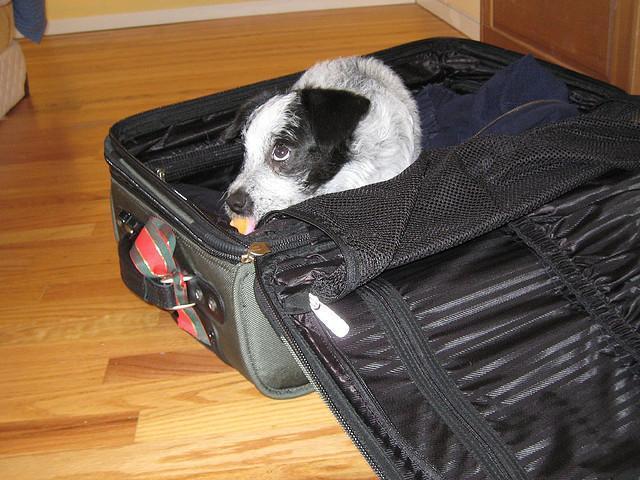How many clock are seen?
Give a very brief answer. 0. 